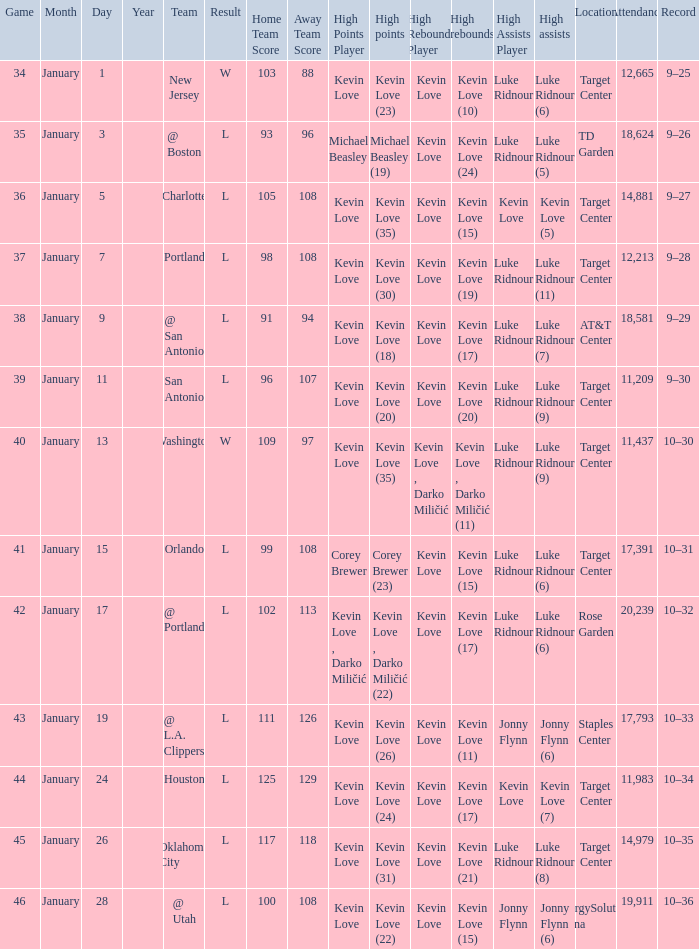Who had the high points when the team was charlotte? Kevin Love (35). 